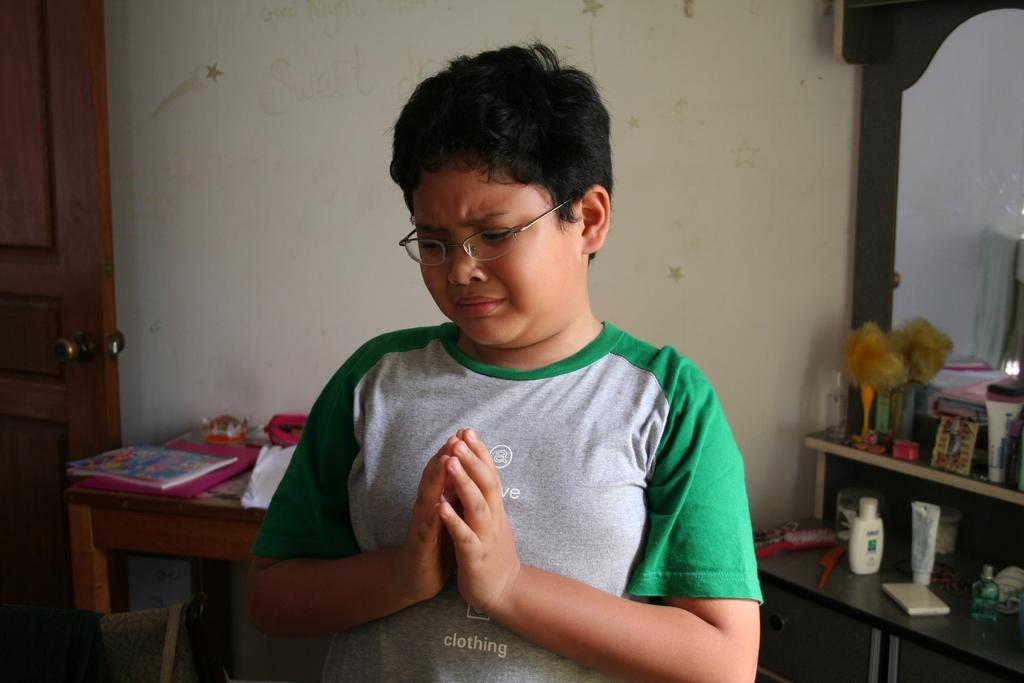Who is the main subject in the image? There is a boy in the image. What is the boy doing in the image? The boy is crying. What is the boy doing with his hands in the image? The boy's hands are together. What objects can be seen on the table in the image? There is a book on a table in the image. What is located on the right side of the image? There is a mirror on the right side of the image. What type of street can be seen in the image? There is no street present in the image. What is the minister doing in the image? There is no minister present in the image. 